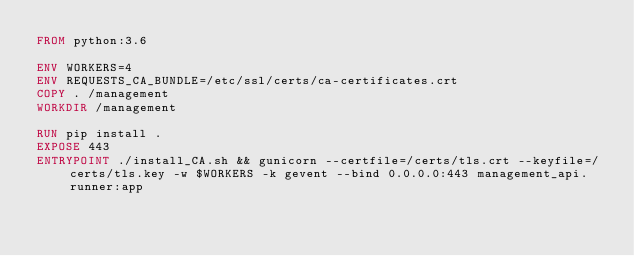Convert code to text. <code><loc_0><loc_0><loc_500><loc_500><_Dockerfile_>FROM python:3.6

ENV WORKERS=4
ENV REQUESTS_CA_BUNDLE=/etc/ssl/certs/ca-certificates.crt
COPY . /management
WORKDIR /management

RUN pip install .
EXPOSE 443
ENTRYPOINT ./install_CA.sh && gunicorn --certfile=/certs/tls.crt --keyfile=/certs/tls.key -w $WORKERS -k gevent --bind 0.0.0.0:443 management_api.runner:app
</code> 